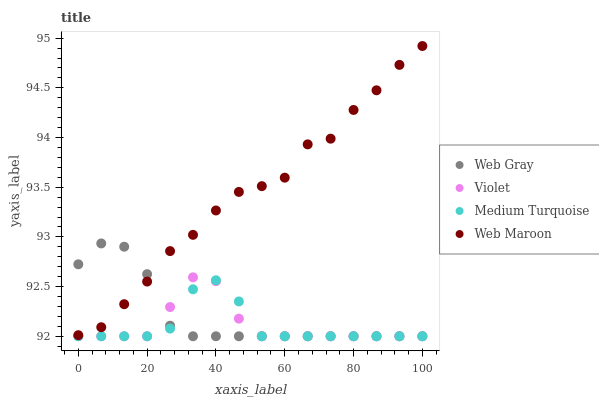Does Medium Turquoise have the minimum area under the curve?
Answer yes or no. Yes. Does Web Maroon have the maximum area under the curve?
Answer yes or no. Yes. Does Web Maroon have the minimum area under the curve?
Answer yes or no. No. Does Medium Turquoise have the maximum area under the curve?
Answer yes or no. No. Is Web Gray the smoothest?
Answer yes or no. Yes. Is Web Maroon the roughest?
Answer yes or no. Yes. Is Medium Turquoise the smoothest?
Answer yes or no. No. Is Medium Turquoise the roughest?
Answer yes or no. No. Does Web Gray have the lowest value?
Answer yes or no. Yes. Does Web Maroon have the lowest value?
Answer yes or no. No. Does Web Maroon have the highest value?
Answer yes or no. Yes. Does Medium Turquoise have the highest value?
Answer yes or no. No. Is Medium Turquoise less than Web Maroon?
Answer yes or no. Yes. Is Web Maroon greater than Medium Turquoise?
Answer yes or no. Yes. Does Web Maroon intersect Web Gray?
Answer yes or no. Yes. Is Web Maroon less than Web Gray?
Answer yes or no. No. Is Web Maroon greater than Web Gray?
Answer yes or no. No. Does Medium Turquoise intersect Web Maroon?
Answer yes or no. No. 